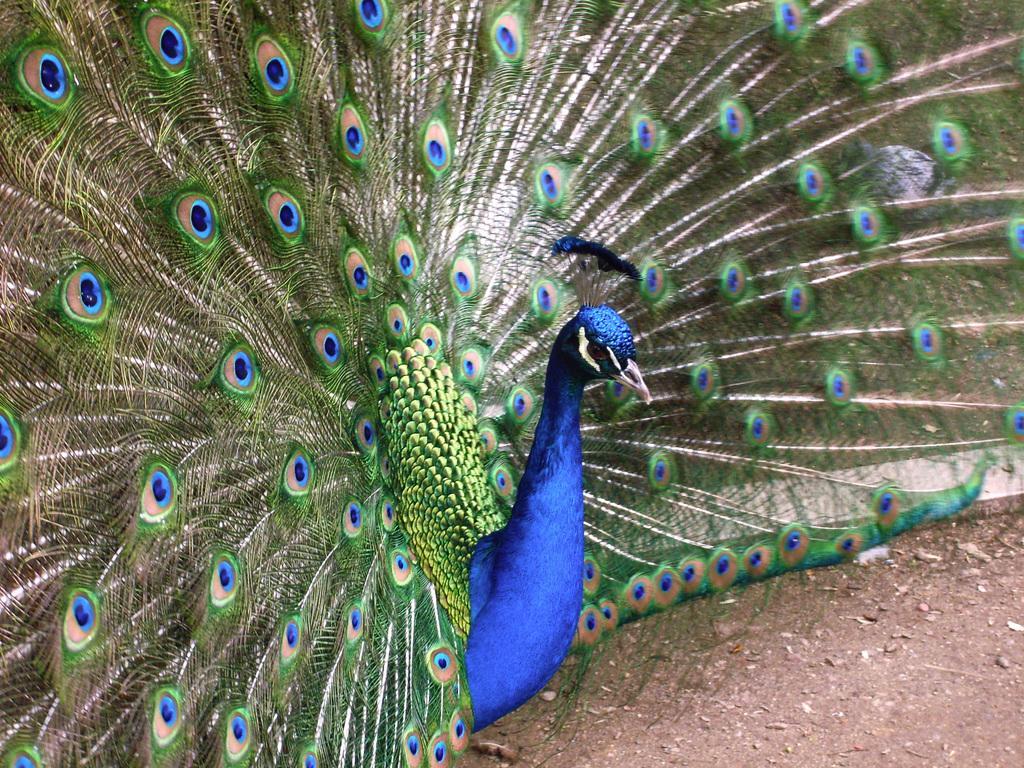Describe this image in one or two sentences. In this image I can see the peacock which is in blue and green color. And it is on the ground. 